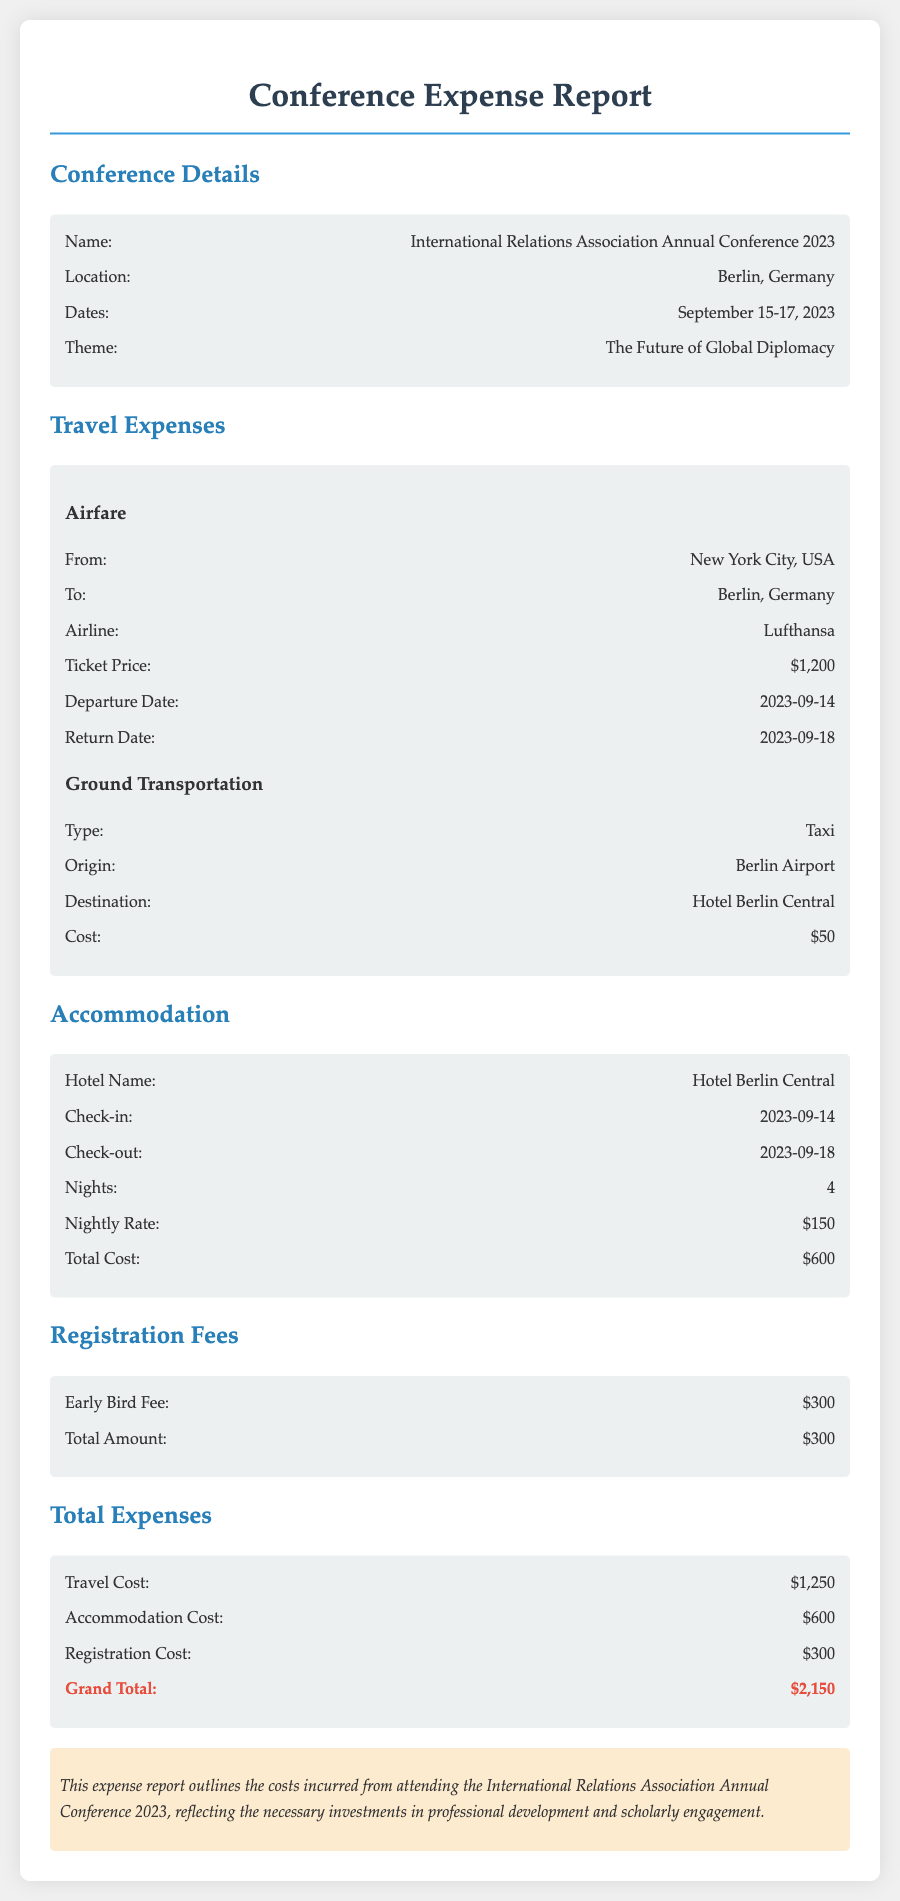What is the conference name? The document states the name of the conference, which is found in the "Conference Details" section.
Answer: International Relations Association Annual Conference 2023 Where is the conference located? The location of the conference is specified in the "Conference Details" section.
Answer: Berlin, Germany What are the dates of the conference? The dates of the conference are mentioned in the "Conference Details" section, covering the specific period.
Answer: September 15-17, 2023 How much was the airfare? The "Travel Expenses" section specifies the price of the airfare clearly.
Answer: $1,200 What is the total accommodation cost? The total accommodation cost is detailed in the "Accommodation" section, showing the total for the stay.
Answer: $600 What is the total amount for registration fees? The amount for registration is outlined in the "Registration Fees" section.
Answer: $300 What is the grand total of expenses? The grand total is calculated by summing up the travel, accommodation, and registration costs as shown in the "Total Expenses" section.
Answer: $2,150 How many nights was the accommodation booked for? The document provides the duration of the stay in the "Accommodation" section.
Answer: 4 What airline was used for travel? The specific airline for the flight is mentioned in the "Travel Expenses" section.
Answer: Lufthansa 